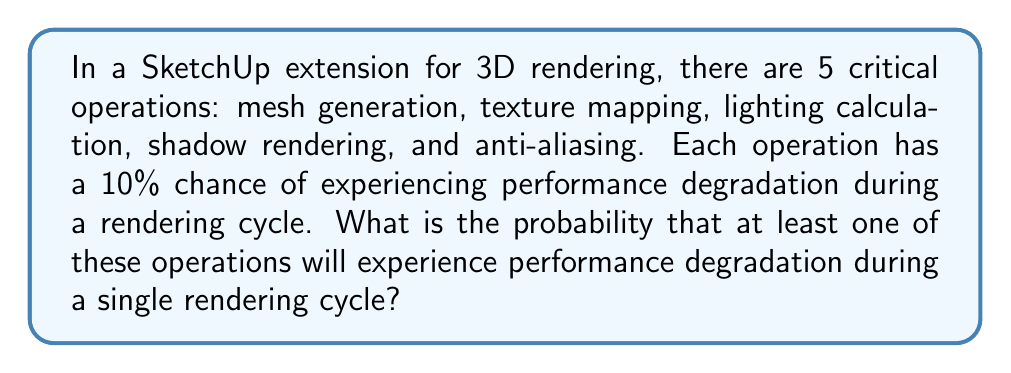Teach me how to tackle this problem. Let's approach this step-by-step:

1) First, we need to calculate the probability that a single operation does not experience performance degradation. This is:

   $1 - 0.10 = 0.90$ or $90\%$

2) For all operations to not experience degradation, we need this to happen for each of the 5 operations independently. We can calculate this using the multiplication rule of probability:

   $P(\text{no degradation}) = 0.90 * 0.90 * 0.90 * 0.90 * 0.90 = 0.90^5$

3) We can calculate this:

   $0.90^5 = 0.59049$

4) This is the probability that none of the operations experience degradation. However, we want the probability that at least one experiences degradation. This is the complement of the probability we just calculated:

   $P(\text{at least one degradation}) = 1 - P(\text{no degradation})$

5) Therefore:

   $P(\text{at least one degradation}) = 1 - 0.59049 = 0.40951$

6) Converting to a percentage:

   $0.40951 * 100\% = 40.951\%$
Answer: $40.951\%$ 